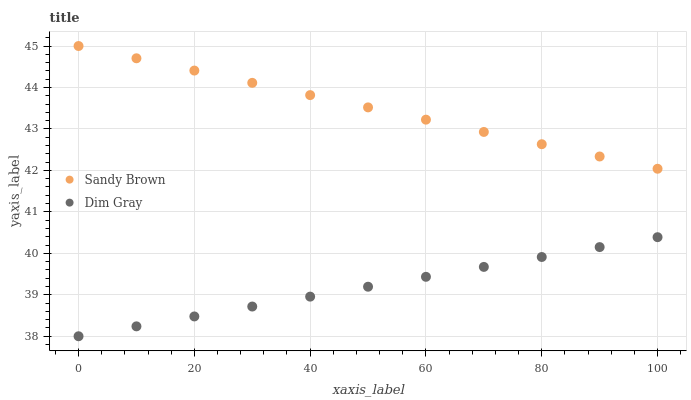Does Dim Gray have the minimum area under the curve?
Answer yes or no. Yes. Does Sandy Brown have the maximum area under the curve?
Answer yes or no. Yes. Does Sandy Brown have the minimum area under the curve?
Answer yes or no. No. Is Sandy Brown the smoothest?
Answer yes or no. Yes. Is Dim Gray the roughest?
Answer yes or no. Yes. Is Sandy Brown the roughest?
Answer yes or no. No. Does Dim Gray have the lowest value?
Answer yes or no. Yes. Does Sandy Brown have the lowest value?
Answer yes or no. No. Does Sandy Brown have the highest value?
Answer yes or no. Yes. Is Dim Gray less than Sandy Brown?
Answer yes or no. Yes. Is Sandy Brown greater than Dim Gray?
Answer yes or no. Yes. Does Dim Gray intersect Sandy Brown?
Answer yes or no. No. 